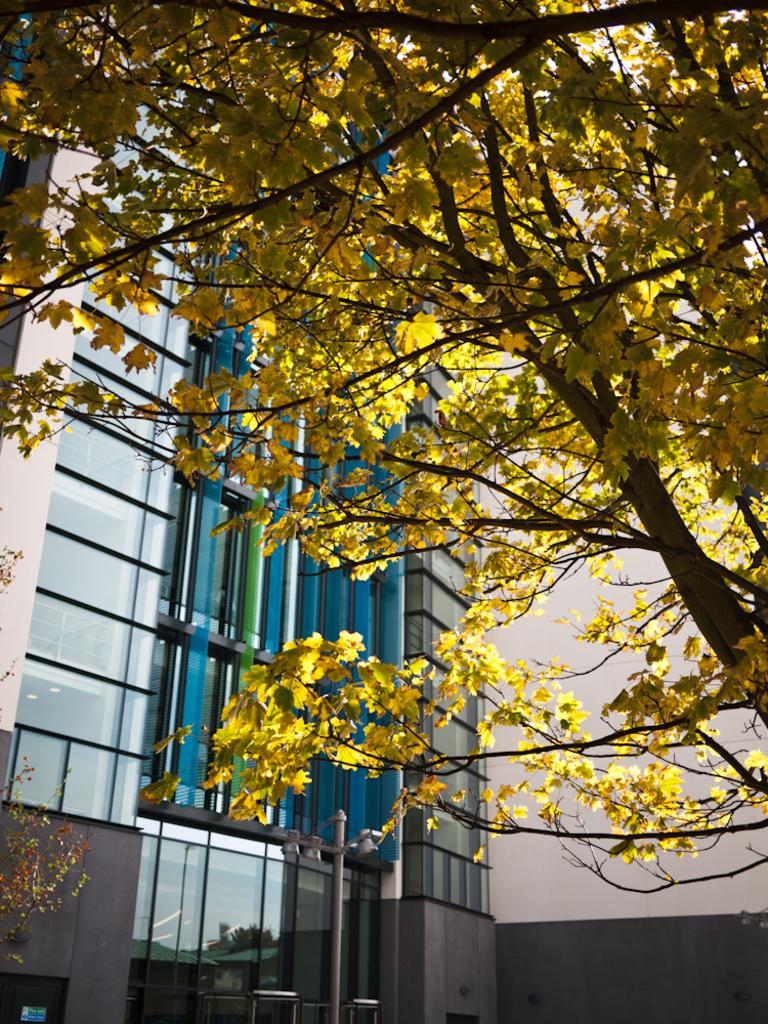What type of structure is present in the image? There is a building in the image. What feature of the building is mentioned in the facts? The building has windows. What else can be seen in the image besides the building? There is a pole, lights, and a tree in the image. What type of drink is being served to the children in the image? There is no mention of children or drinks in the image; it only features a building, windows, a pole, lights, and a tree. 